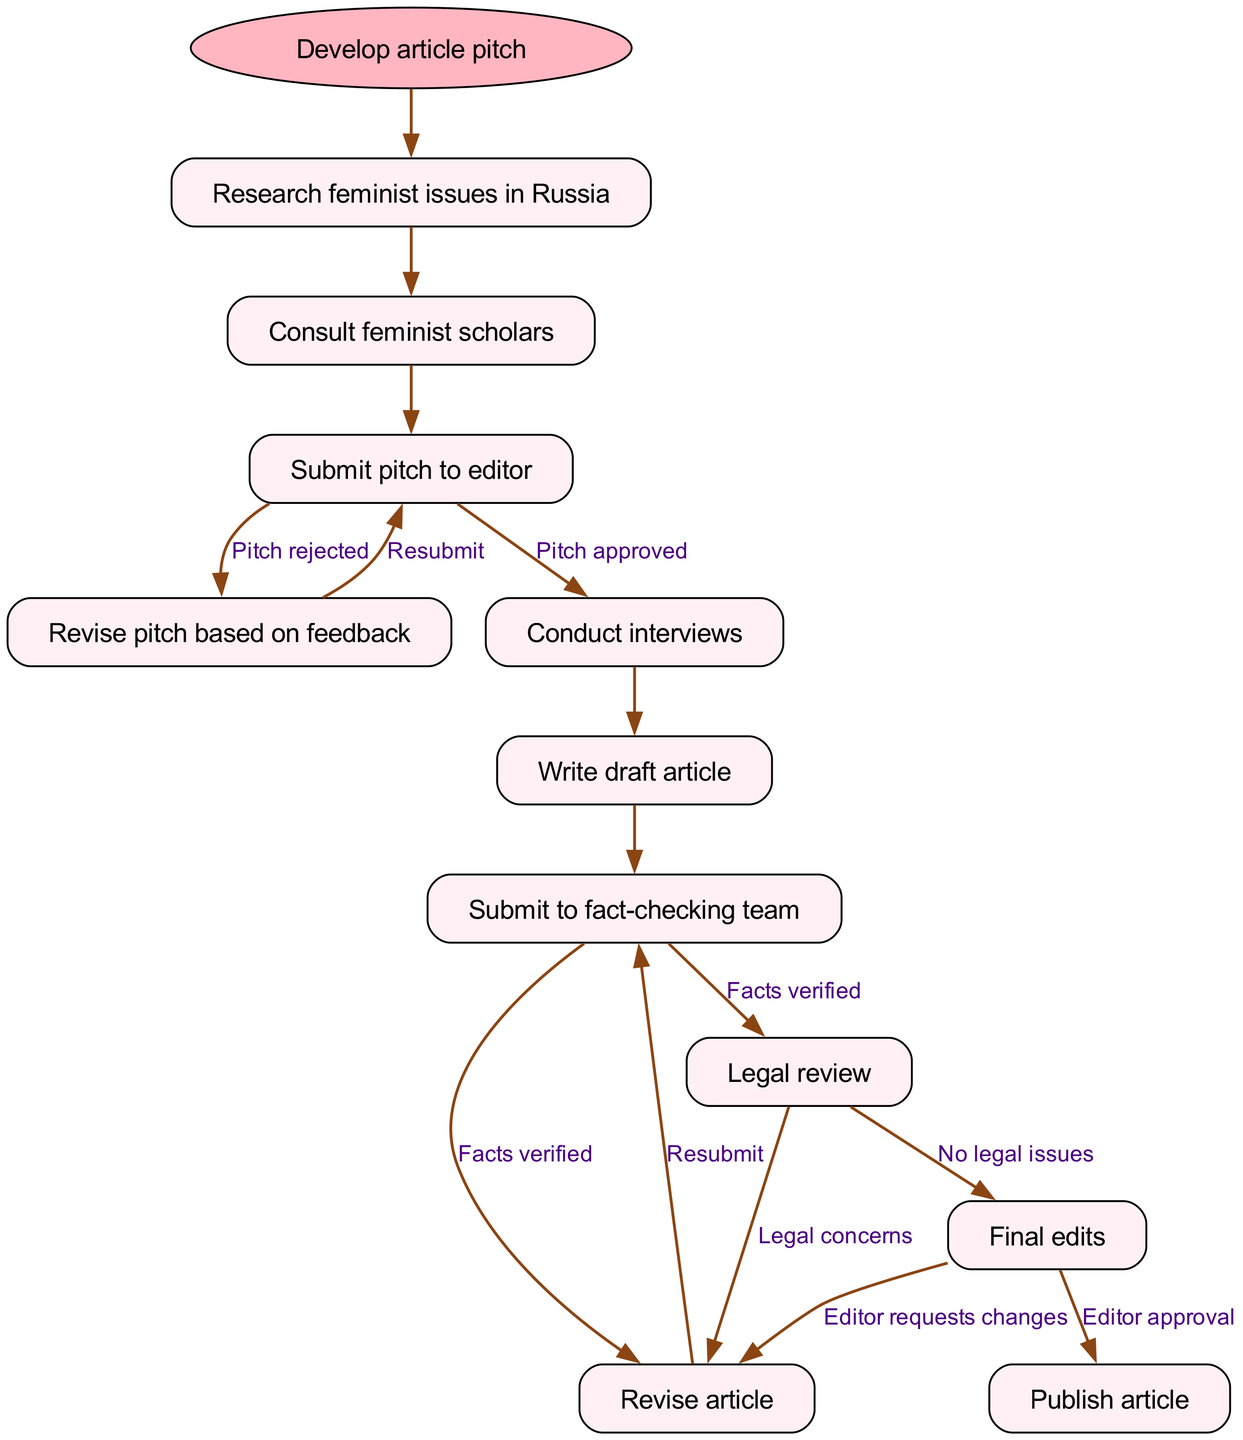What is the first step in the diagram? The diagram starts with the node labeled "Develop article pitch," which is represented as the first action in the journey of the feminist-themed article.
Answer: Develop article pitch How many nodes are present in the diagram? The diagram includes a series of nodes that depict the different steps in the article's journey. Counting them, we find that there are 11 nodes in total.
Answer: 11 What happens after the pitch is submitted to the editor? Following the "Submit pitch to editor" node, there are two possible outcomes indicated. The flow can proceed to either "Revise pitch based on feedback" (if rejected) or "Conduct interviews" (if approved).
Answer: Revise pitch based on feedback, Conduct interviews Which node comes before the "Final edits" node? The node that directly precedes "Final edits" in the flow is "Legal review." The journey requires the legal review process to be completed before any final edits can take place.
Answer: Legal review What are the two possible outcomes after submitting the pitch to the editor? After submitting the pitch to the editor, the results can either be a "Pitch approved" leading to "Conduct interviews" or a "Pitch rejected," which requires a "Revise pitch based on feedback." Thus, two paths stem from this point.
Answer: Pitch approved, Pitch rejected How does the process proceed if there are legal concerns? If legal concerns are present after the "Legal review," the process returns to the "Revise article" node to address those issues before moving on again. This creates a loop in the process until legal concerns are resolved.
Answer: Revise article What is the last step in the article journey? The final step indicated in the flowchart is "Publish article," signifying the completion of the article's journey once all preceding steps are finalized.
Answer: Publish article What happens after the article is submitted to the fact-checking team? After the article is submitted to the fact-checking team, it either leads to "Revise article" if facts are verified, or it might return for further fact-checking if issues are found. This creates a feedback loop in the workflow.
Answer: Revise article What is the outcome if the pitch is approved? If the pitch is approved, it enables the writer to proceed directly to conducting interviews, which is the next step in the diagram's flow.
Answer: Conduct interviews 